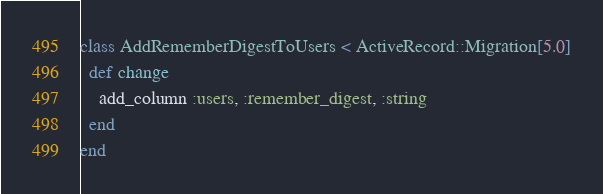Convert code to text. <code><loc_0><loc_0><loc_500><loc_500><_Ruby_>class AddRememberDigestToUsers < ActiveRecord::Migration[5.0]
  def change
    add_column :users, :remember_digest, :string
  end
end
</code> 